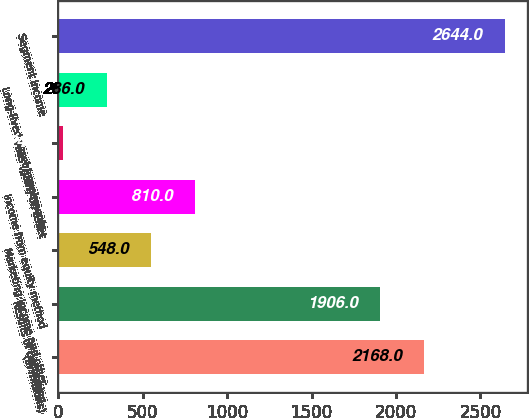Convert chart to OTSL. <chart><loc_0><loc_0><loc_500><loc_500><bar_chart><fcel>(In millions)<fcel>Results of continuing<fcel>Marketing income and other<fcel>Income from equity method<fcel>Loss (gain) on asset<fcel>Long-lived asset impairments<fcel>Segment income<nl><fcel>2168<fcel>1906<fcel>548<fcel>810<fcel>24<fcel>286<fcel>2644<nl></chart> 